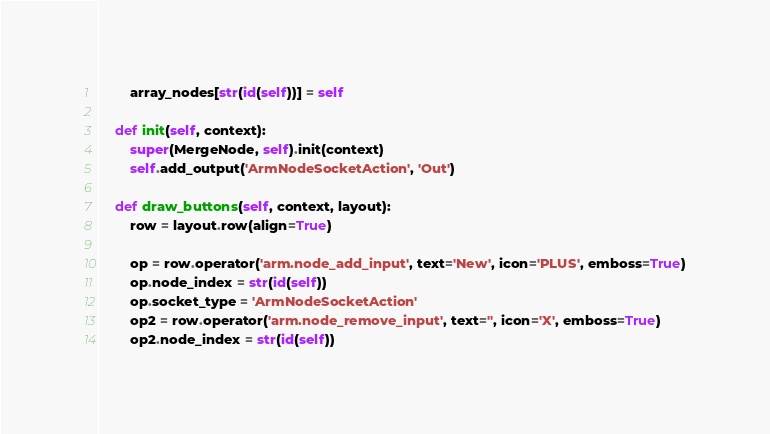<code> <loc_0><loc_0><loc_500><loc_500><_Python_>        array_nodes[str(id(self))] = self

    def init(self, context):
        super(MergeNode, self).init(context)
        self.add_output('ArmNodeSocketAction', 'Out')

    def draw_buttons(self, context, layout):
        row = layout.row(align=True)

        op = row.operator('arm.node_add_input', text='New', icon='PLUS', emboss=True)
        op.node_index = str(id(self))
        op.socket_type = 'ArmNodeSocketAction'
        op2 = row.operator('arm.node_remove_input', text='', icon='X', emboss=True)
        op2.node_index = str(id(self))
</code> 